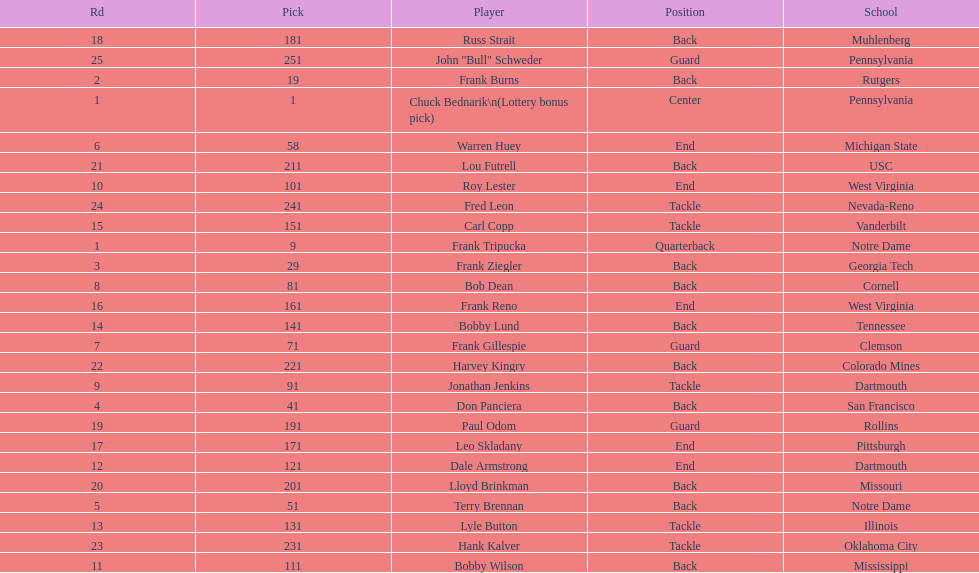Can you give me this table as a dict? {'header': ['Rd', 'Pick', 'Player', 'Position', 'School'], 'rows': [['18', '181', 'Russ Strait', 'Back', 'Muhlenberg'], ['25', '251', 'John "Bull" Schweder', 'Guard', 'Pennsylvania'], ['2', '19', 'Frank Burns', 'Back', 'Rutgers'], ['1', '1', 'Chuck Bednarik\\n(Lottery bonus pick)', 'Center', 'Pennsylvania'], ['6', '58', 'Warren Huey', 'End', 'Michigan State'], ['21', '211', 'Lou Futrell', 'Back', 'USC'], ['10', '101', 'Roy Lester', 'End', 'West Virginia'], ['24', '241', 'Fred Leon', 'Tackle', 'Nevada-Reno'], ['15', '151', 'Carl Copp', 'Tackle', 'Vanderbilt'], ['1', '9', 'Frank Tripucka', 'Quarterback', 'Notre Dame'], ['3', '29', 'Frank Ziegler', 'Back', 'Georgia Tech'], ['8', '81', 'Bob Dean', 'Back', 'Cornell'], ['16', '161', 'Frank Reno', 'End', 'West Virginia'], ['14', '141', 'Bobby Lund', 'Back', 'Tennessee'], ['7', '71', 'Frank Gillespie', 'Guard', 'Clemson'], ['22', '221', 'Harvey Kingry', 'Back', 'Colorado Mines'], ['9', '91', 'Jonathan Jenkins', 'Tackle', 'Dartmouth'], ['4', '41', 'Don Panciera', 'Back', 'San Francisco'], ['19', '191', 'Paul Odom', 'Guard', 'Rollins'], ['17', '171', 'Leo Skladany', 'End', 'Pittsburgh'], ['12', '121', 'Dale Armstrong', 'End', 'Dartmouth'], ['20', '201', 'Lloyd Brinkman', 'Back', 'Missouri'], ['5', '51', 'Terry Brennan', 'Back', 'Notre Dame'], ['13', '131', 'Lyle Button', 'Tackle', 'Illinois'], ['23', '231', 'Hank Kalver', 'Tackle', 'Oklahoma City'], ['11', '111', 'Bobby Wilson', 'Back', 'Mississippi']]} Was chuck bednarik or frank tripucka the first draft pick? Chuck Bednarik. 